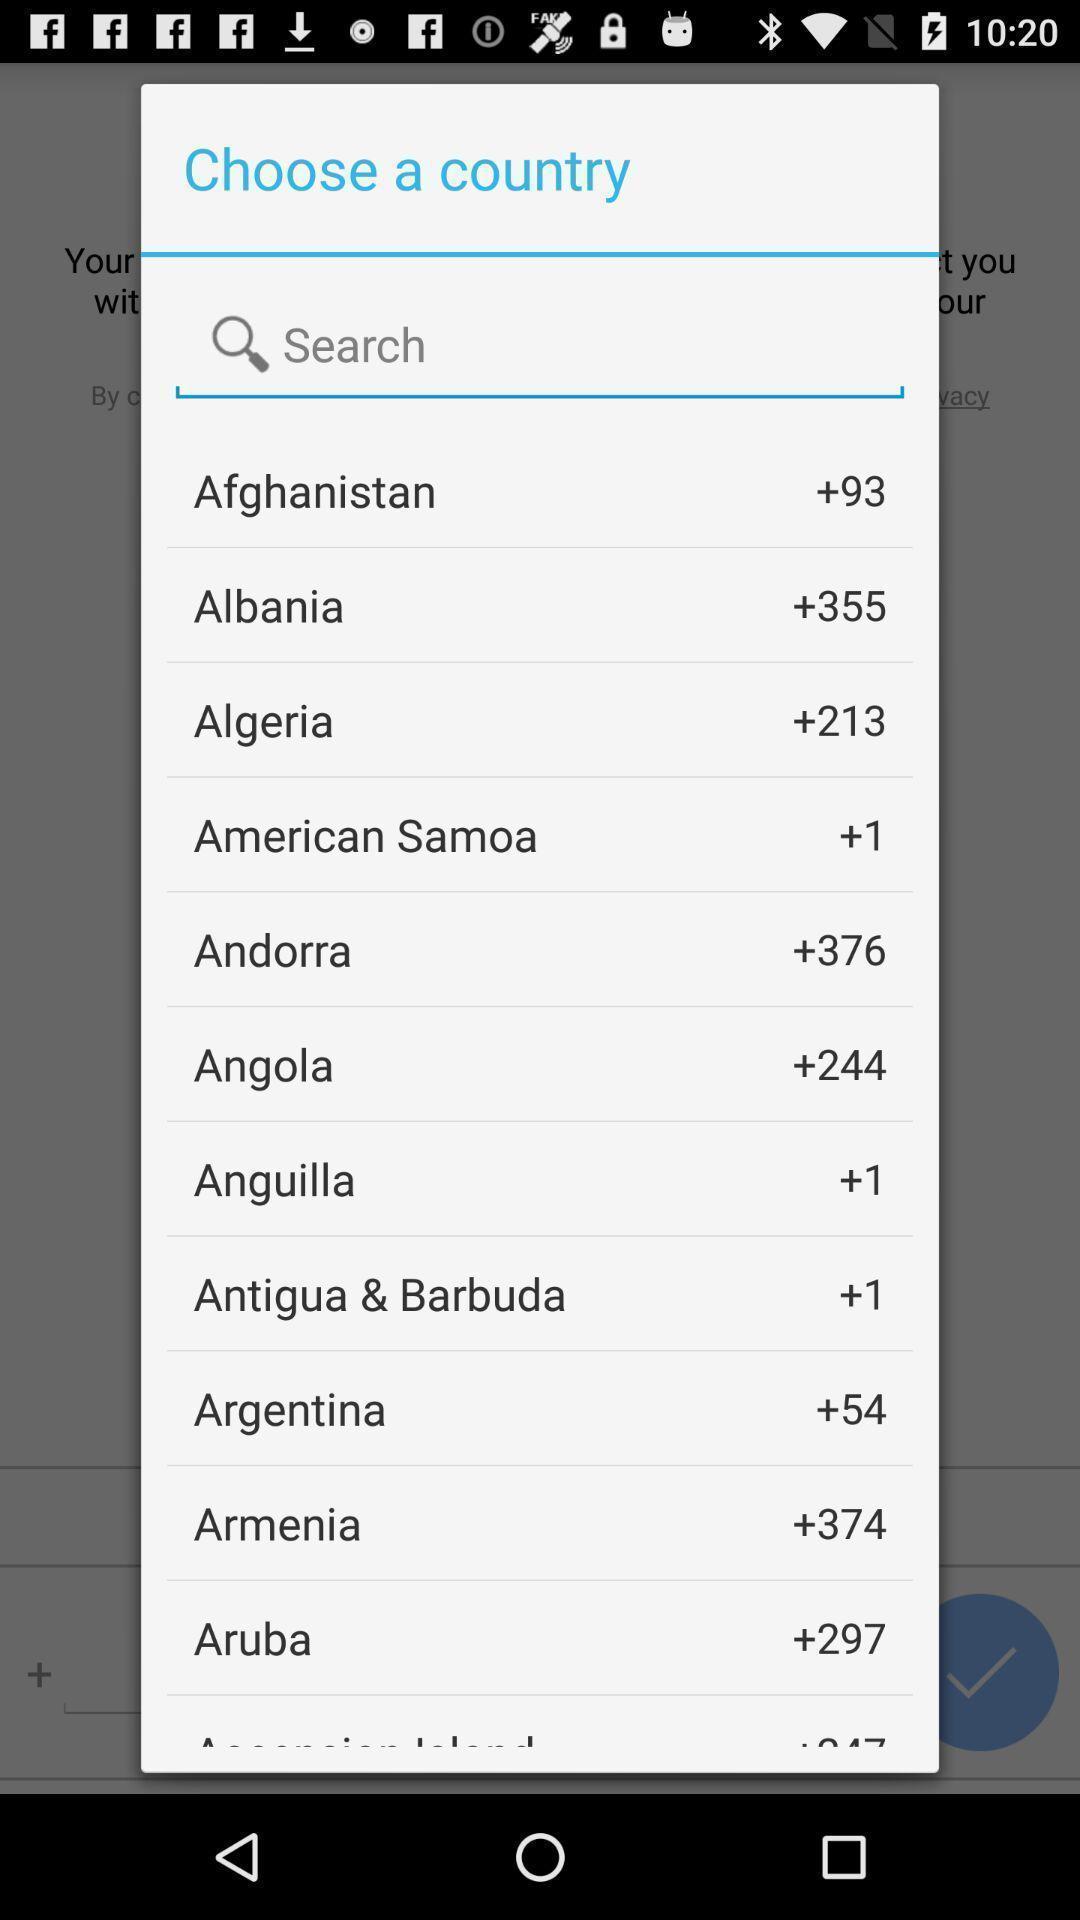Provide a detailed account of this screenshot. Pop-up with country selection in a messaging app. 